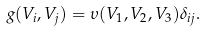<formula> <loc_0><loc_0><loc_500><loc_500>g ( V _ { i } , V _ { j } ) = \upsilon ( V _ { 1 } , V _ { 2 } , V _ { 3 } ) \delta _ { i j } .</formula> 